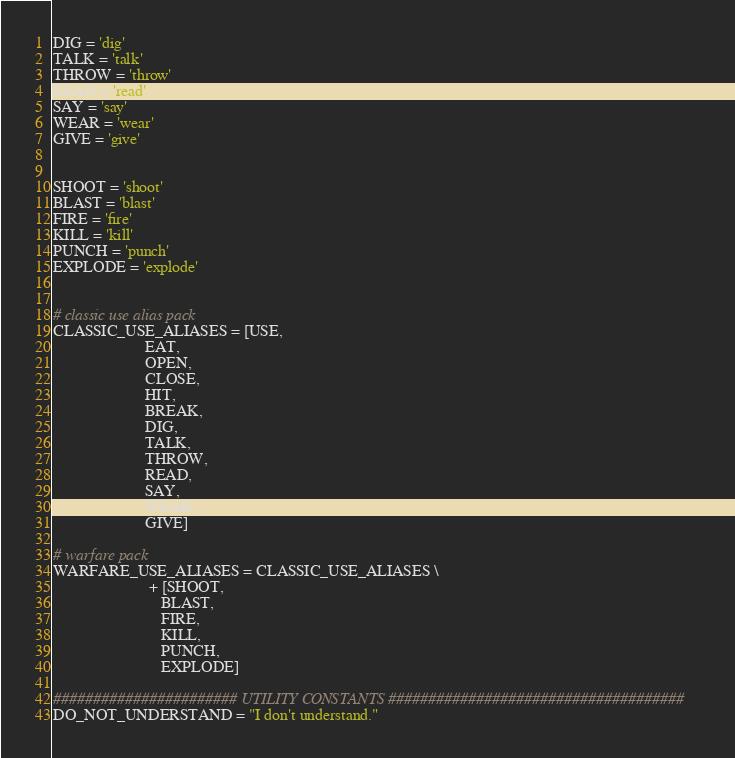Convert code to text. <code><loc_0><loc_0><loc_500><loc_500><_Python_>DIG = 'dig'
TALK = 'talk'
THROW = 'throw'
READ = 'read'
SAY = 'say'
WEAR = 'wear'
GIVE = 'give'


SHOOT = 'shoot'
BLAST = 'blast'
FIRE = 'fire'
KILL = 'kill'
PUNCH = 'punch'
EXPLODE = 'explode'


# classic use alias pack
CLASSIC_USE_ALIASES = [USE,
                       EAT,
                       OPEN,
                       CLOSE,
                       HIT,
                       BREAK,
                       DIG,
                       TALK,
                       THROW,
                       READ,
                       SAY,
                       WEAR,
                       GIVE]

# warfare pack
WARFARE_USE_ALIASES = CLASSIC_USE_ALIASES \
                        + [SHOOT,
                           BLAST,
                           FIRE,
                           KILL,
                           PUNCH,
                           EXPLODE]

####################### UTILITY CONSTANTS #####################################
DO_NOT_UNDERSTAND = "I don't understand."
</code> 